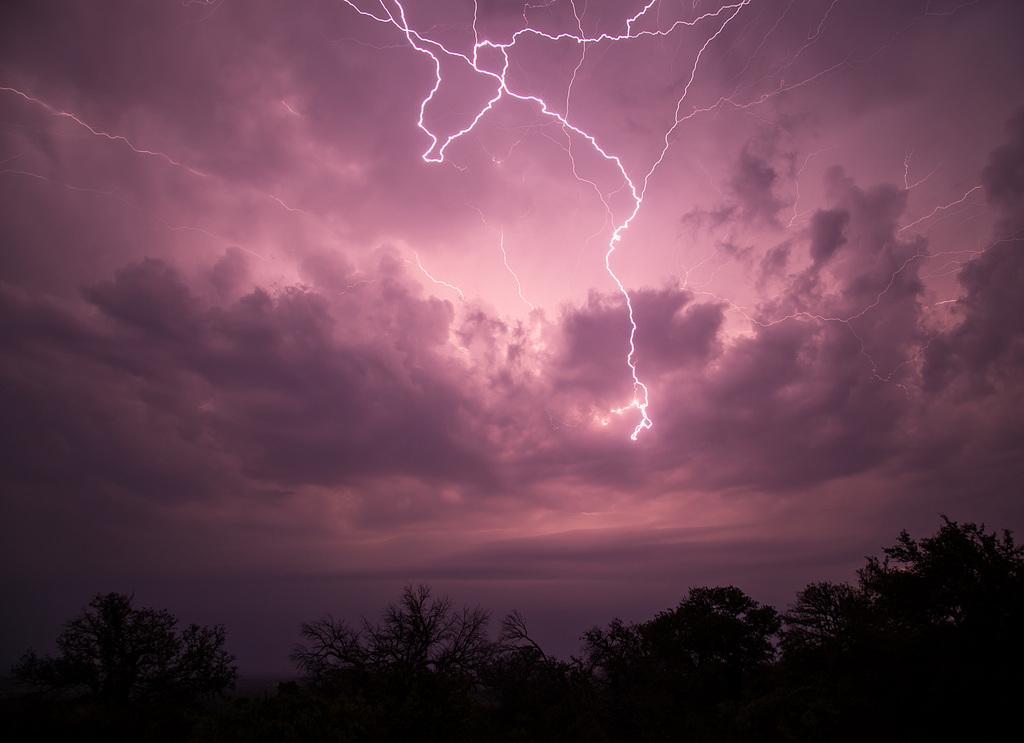Please provide a concise description of this image. In this image there are trees, at the top of the image there are clouds and thunder in the sky. 